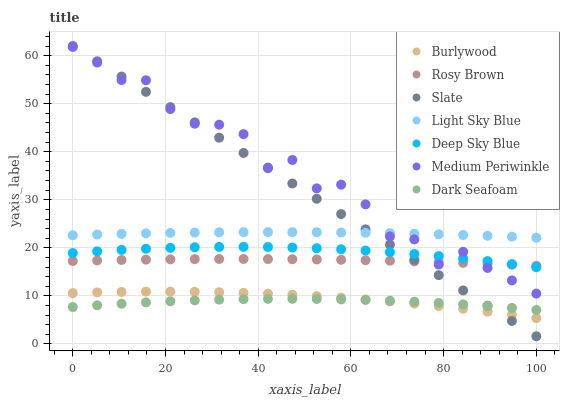Does Dark Seafoam have the minimum area under the curve?
Answer yes or no. Yes. Does Medium Periwinkle have the maximum area under the curve?
Answer yes or no. Yes. Does Slate have the minimum area under the curve?
Answer yes or no. No. Does Slate have the maximum area under the curve?
Answer yes or no. No. Is Slate the smoothest?
Answer yes or no. Yes. Is Medium Periwinkle the roughest?
Answer yes or no. Yes. Is Rosy Brown the smoothest?
Answer yes or no. No. Is Rosy Brown the roughest?
Answer yes or no. No. Does Slate have the lowest value?
Answer yes or no. Yes. Does Rosy Brown have the lowest value?
Answer yes or no. No. Does Slate have the highest value?
Answer yes or no. Yes. Does Rosy Brown have the highest value?
Answer yes or no. No. Is Dark Seafoam less than Deep Sky Blue?
Answer yes or no. Yes. Is Light Sky Blue greater than Burlywood?
Answer yes or no. Yes. Does Medium Periwinkle intersect Slate?
Answer yes or no. Yes. Is Medium Periwinkle less than Slate?
Answer yes or no. No. Is Medium Periwinkle greater than Slate?
Answer yes or no. No. Does Dark Seafoam intersect Deep Sky Blue?
Answer yes or no. No. 